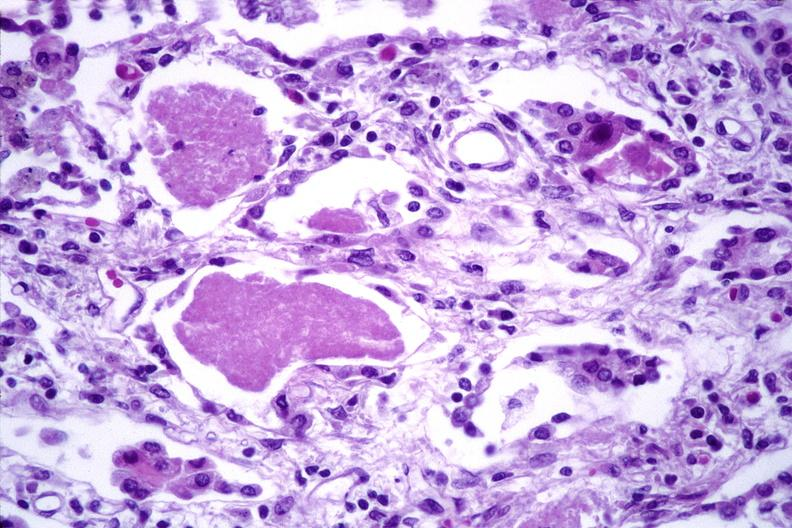where is this?
Answer the question using a single word or phrase. Lung 